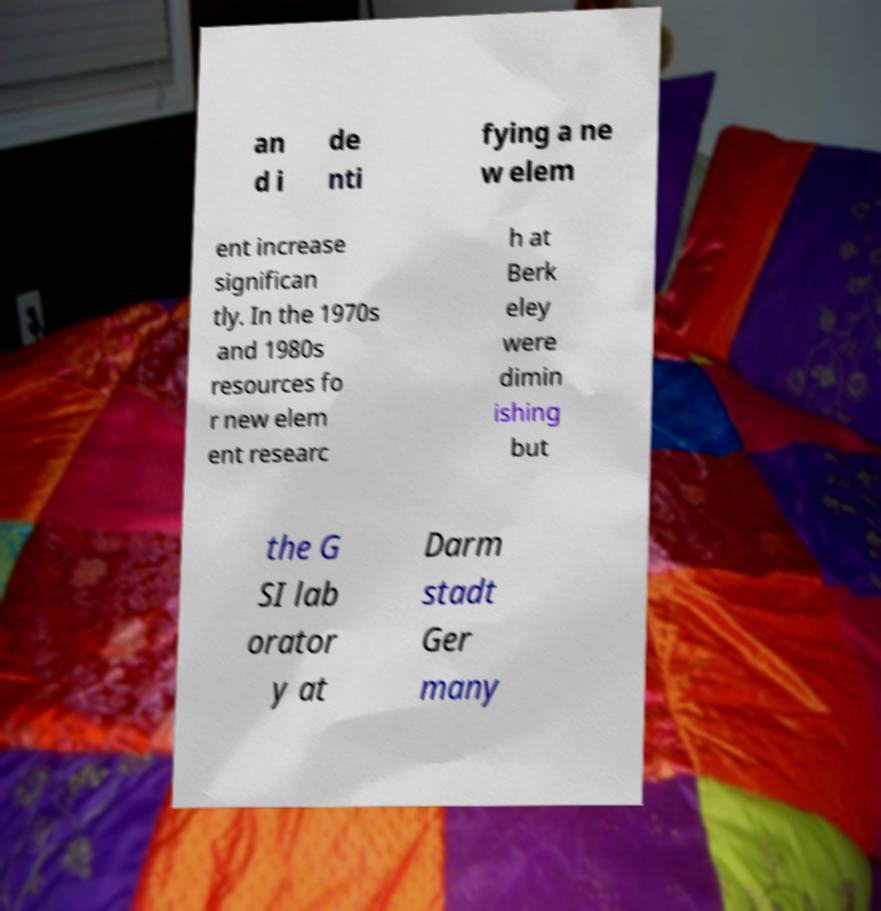I need the written content from this picture converted into text. Can you do that? an d i de nti fying a ne w elem ent increase significan tly. In the 1970s and 1980s resources fo r new elem ent researc h at Berk eley were dimin ishing but the G SI lab orator y at Darm stadt Ger many 